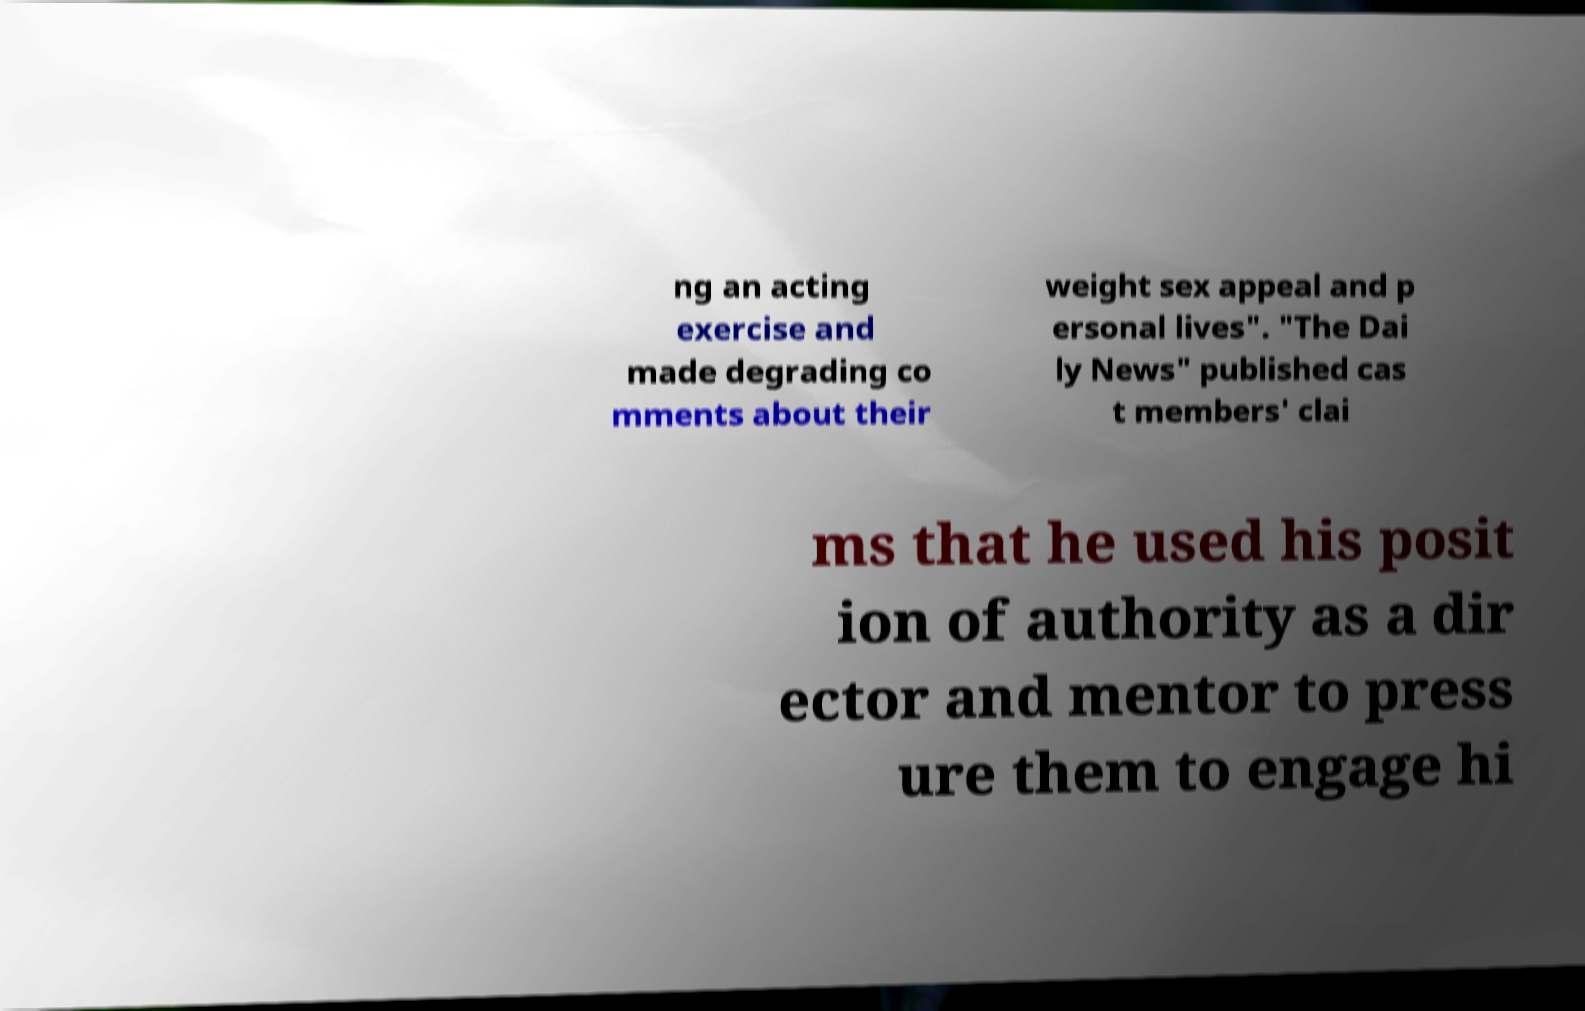There's text embedded in this image that I need extracted. Can you transcribe it verbatim? ng an acting exercise and made degrading co mments about their weight sex appeal and p ersonal lives". "The Dai ly News" published cas t members' clai ms that he used his posit ion of authority as a dir ector and mentor to press ure them to engage hi 